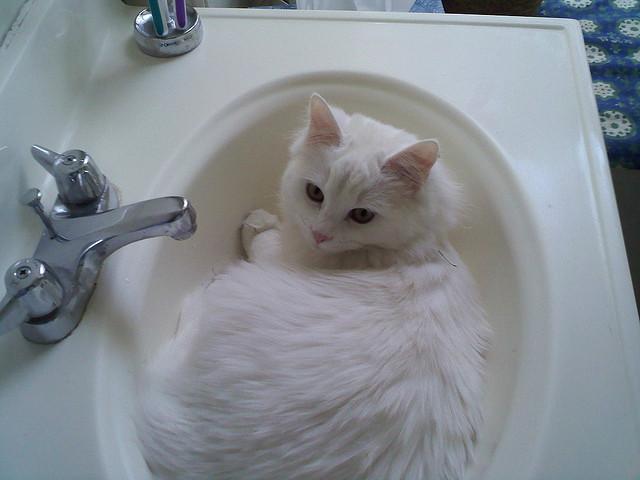What color is the animal?
Keep it brief. White. How many ears does the cat have?
Write a very short answer. 2. What is the cat doing?
Be succinct. Laying in sink. Is the cat in the sink?
Give a very brief answer. Yes. Should the cat be here?
Concise answer only. No. Is this a pet bed?
Be succinct. No. 